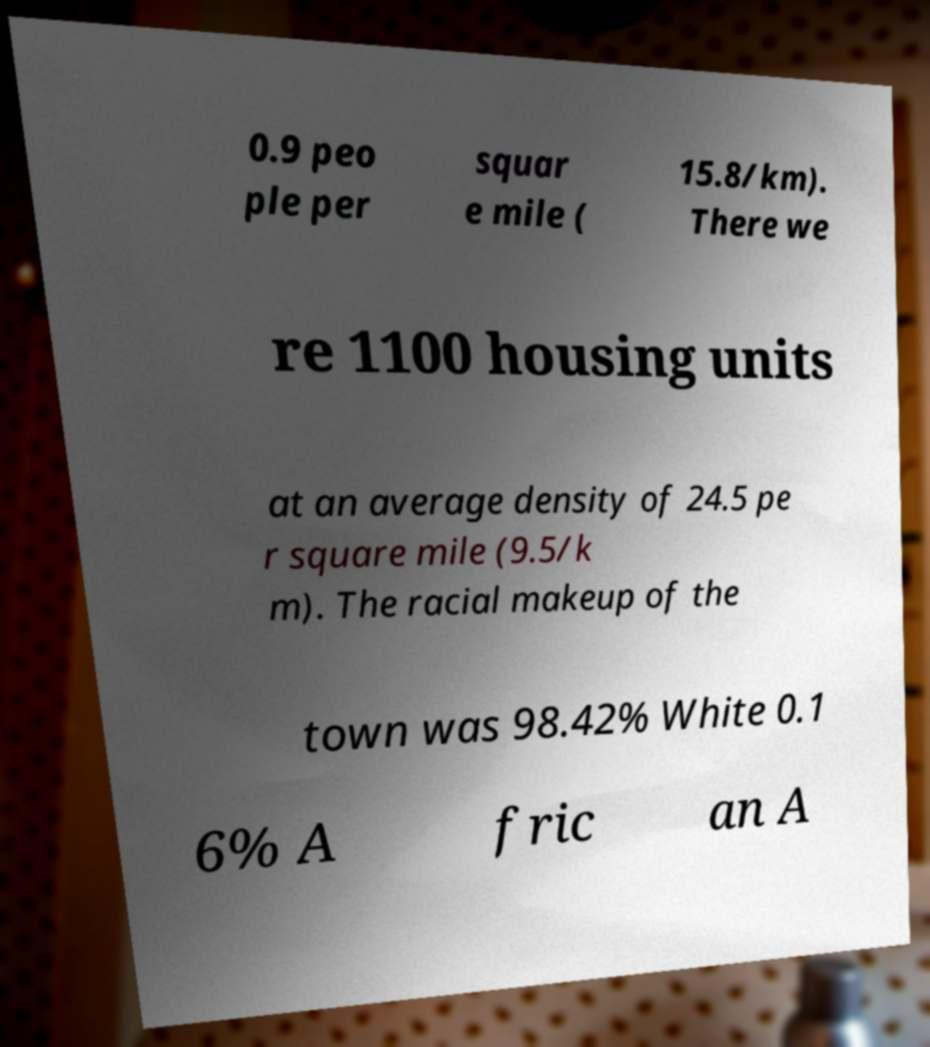Please read and relay the text visible in this image. What does it say? 0.9 peo ple per squar e mile ( 15.8/km). There we re 1100 housing units at an average density of 24.5 pe r square mile (9.5/k m). The racial makeup of the town was 98.42% White 0.1 6% A fric an A 